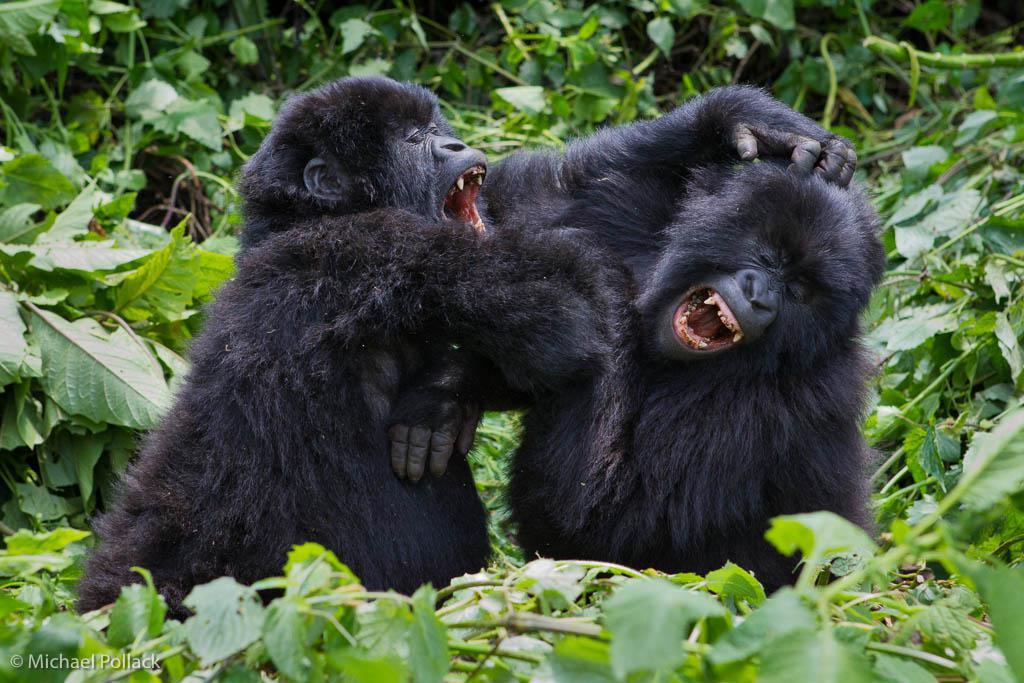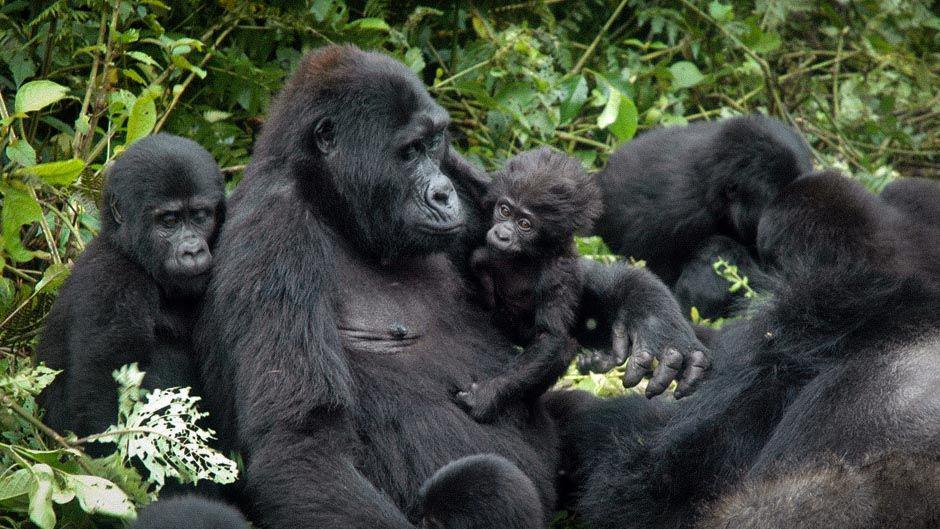The first image is the image on the left, the second image is the image on the right. Given the left and right images, does the statement "to the left, two simians appear to be playfully irritated at each other." hold true? Answer yes or no. Yes. The first image is the image on the left, the second image is the image on the right. Given the left and right images, does the statement "An image shows exactly two furry apes wrestling each other, both with wide-open mouths." hold true? Answer yes or no. Yes. 